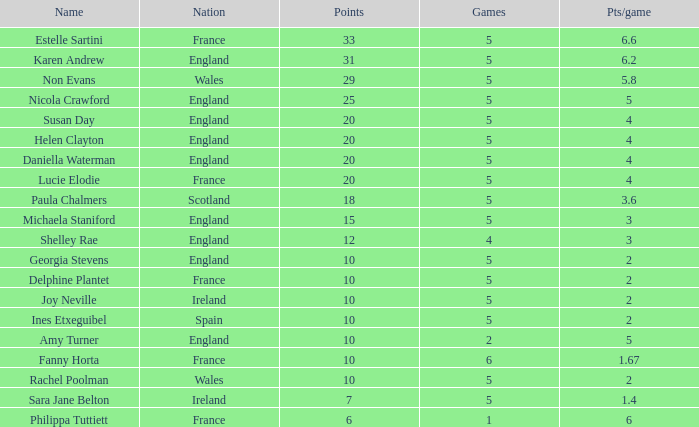Can you tell me the lowest Pts/game that has the Name of philippa tuttiett, and the Points larger then 6? None. 